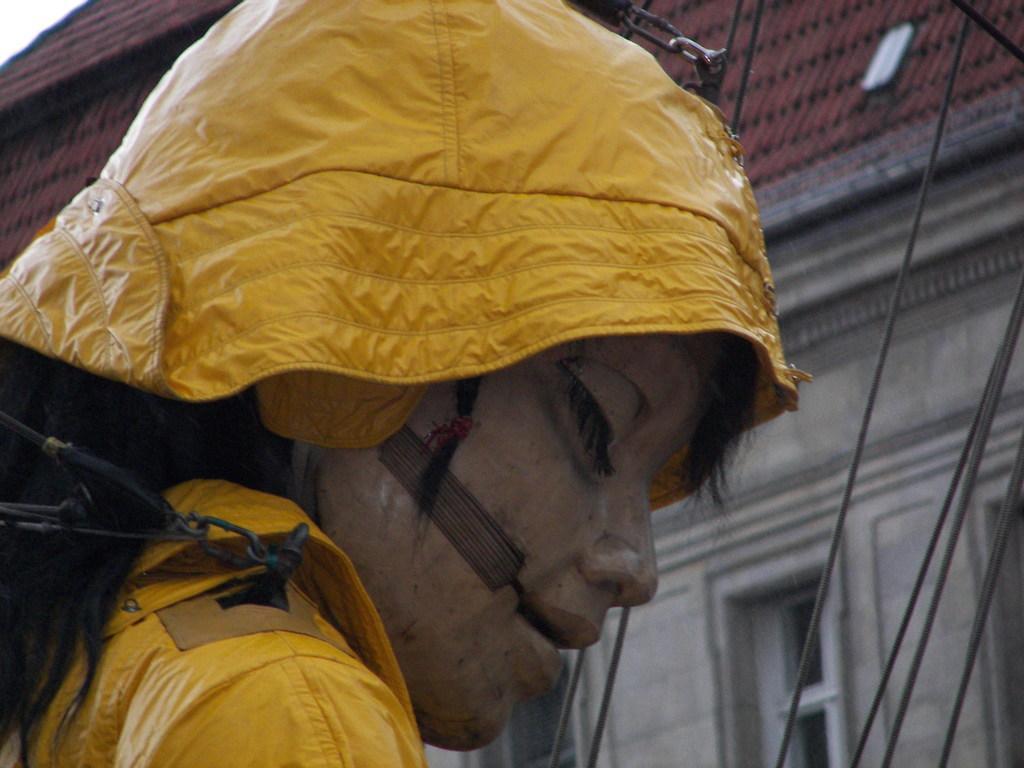How would you summarize this image in a sentence or two? In this image I can see a doll wearing yellow colored dress. In the background I can see few wires, a building which is cream and brown in color and the sky. 